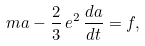<formula> <loc_0><loc_0><loc_500><loc_500>m { a } - \frac { 2 } { 3 } \, e ^ { 2 } \, \frac { d { a } } { d t } = { f } ,</formula> 